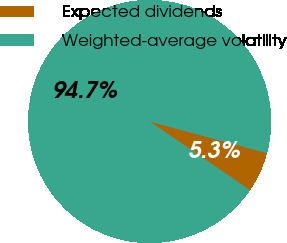Convert chart to OTSL. <chart><loc_0><loc_0><loc_500><loc_500><pie_chart><fcel>Expected dividends<fcel>Weighted-average volatility<nl><fcel>5.35%<fcel>94.65%<nl></chart> 